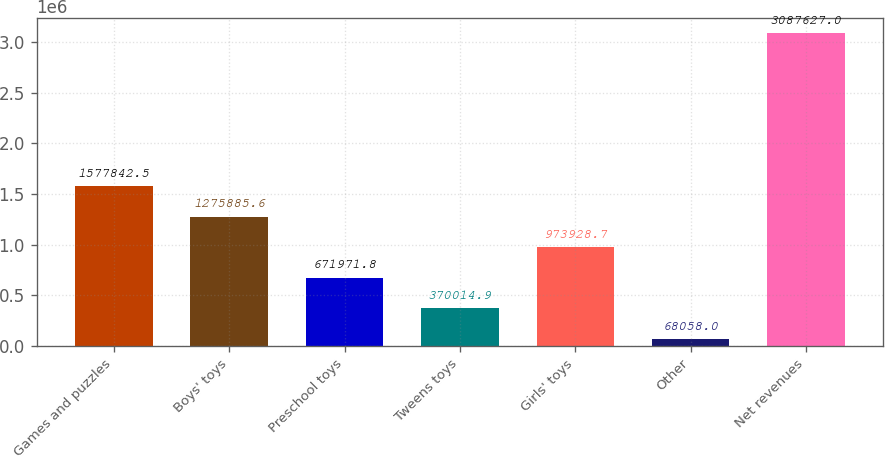Convert chart to OTSL. <chart><loc_0><loc_0><loc_500><loc_500><bar_chart><fcel>Games and puzzles<fcel>Boys' toys<fcel>Preschool toys<fcel>Tweens toys<fcel>Girls' toys<fcel>Other<fcel>Net revenues<nl><fcel>1.57784e+06<fcel>1.27589e+06<fcel>671972<fcel>370015<fcel>973929<fcel>68058<fcel>3.08763e+06<nl></chart> 